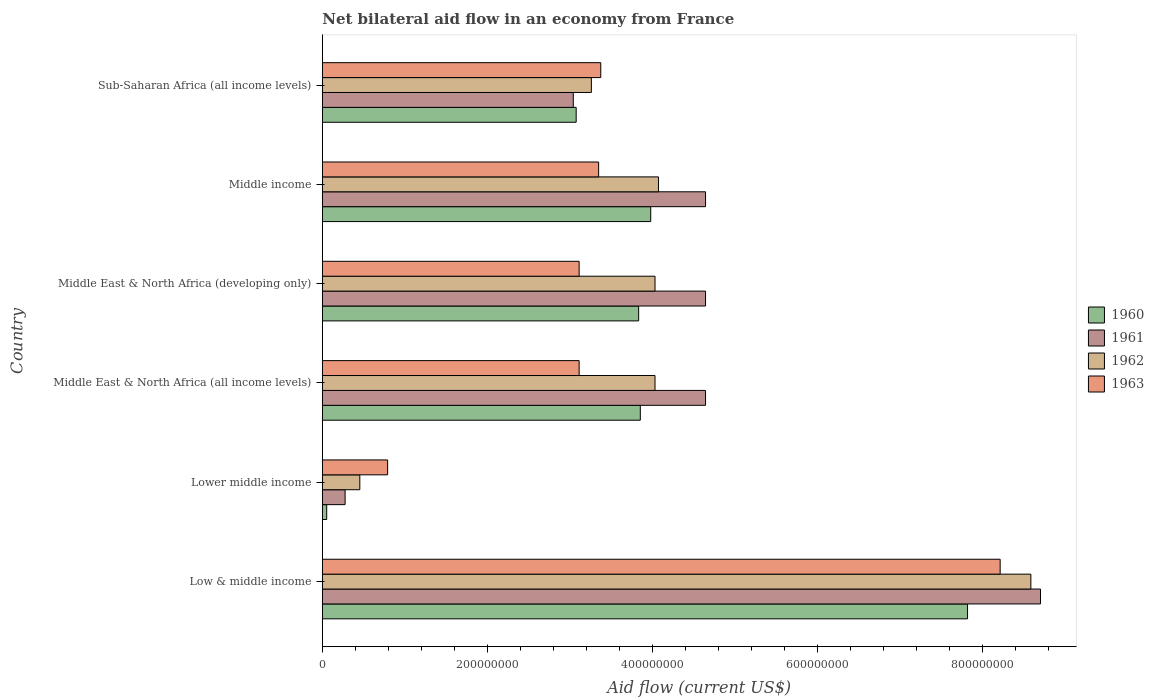How many different coloured bars are there?
Make the answer very short. 4. How many groups of bars are there?
Offer a very short reply. 6. How many bars are there on the 6th tick from the bottom?
Provide a short and direct response. 4. What is the label of the 2nd group of bars from the top?
Ensure brevity in your answer.  Middle income. What is the net bilateral aid flow in 1961 in Middle East & North Africa (all income levels)?
Give a very brief answer. 4.64e+08. Across all countries, what is the maximum net bilateral aid flow in 1960?
Your answer should be very brief. 7.82e+08. Across all countries, what is the minimum net bilateral aid flow in 1963?
Your answer should be compact. 7.91e+07. In which country was the net bilateral aid flow in 1960 maximum?
Give a very brief answer. Low & middle income. In which country was the net bilateral aid flow in 1963 minimum?
Keep it short and to the point. Lower middle income. What is the total net bilateral aid flow in 1962 in the graph?
Provide a short and direct response. 2.44e+09. What is the difference between the net bilateral aid flow in 1960 in Middle East & North Africa (developing only) and that in Sub-Saharan Africa (all income levels)?
Make the answer very short. 7.57e+07. What is the difference between the net bilateral aid flow in 1963 in Middle income and the net bilateral aid flow in 1960 in Middle East & North Africa (developing only)?
Ensure brevity in your answer.  -4.85e+07. What is the average net bilateral aid flow in 1962 per country?
Offer a terse response. 4.07e+08. What is the difference between the net bilateral aid flow in 1963 and net bilateral aid flow in 1962 in Sub-Saharan Africa (all income levels)?
Offer a very short reply. 1.14e+07. In how many countries, is the net bilateral aid flow in 1961 greater than 400000000 US$?
Ensure brevity in your answer.  4. What is the ratio of the net bilateral aid flow in 1963 in Lower middle income to that in Sub-Saharan Africa (all income levels)?
Make the answer very short. 0.23. Is the net bilateral aid flow in 1962 in Lower middle income less than that in Middle income?
Offer a terse response. Yes. Is the difference between the net bilateral aid flow in 1963 in Middle East & North Africa (developing only) and Middle income greater than the difference between the net bilateral aid flow in 1962 in Middle East & North Africa (developing only) and Middle income?
Keep it short and to the point. No. What is the difference between the highest and the second highest net bilateral aid flow in 1961?
Provide a succinct answer. 4.06e+08. What is the difference between the highest and the lowest net bilateral aid flow in 1961?
Your answer should be compact. 8.42e+08. What does the 1st bar from the top in Lower middle income represents?
Your answer should be very brief. 1963. Are all the bars in the graph horizontal?
Ensure brevity in your answer.  Yes. How many countries are there in the graph?
Ensure brevity in your answer.  6. What is the difference between two consecutive major ticks on the X-axis?
Offer a very short reply. 2.00e+08. Does the graph contain any zero values?
Offer a very short reply. No. Does the graph contain grids?
Offer a terse response. No. How many legend labels are there?
Your response must be concise. 4. How are the legend labels stacked?
Provide a short and direct response. Vertical. What is the title of the graph?
Keep it short and to the point. Net bilateral aid flow in an economy from France. Does "2006" appear as one of the legend labels in the graph?
Give a very brief answer. No. What is the Aid flow (current US$) in 1960 in Low & middle income?
Your answer should be compact. 7.82e+08. What is the Aid flow (current US$) in 1961 in Low & middle income?
Offer a very short reply. 8.70e+08. What is the Aid flow (current US$) of 1962 in Low & middle income?
Provide a short and direct response. 8.58e+08. What is the Aid flow (current US$) of 1963 in Low & middle income?
Ensure brevity in your answer.  8.21e+08. What is the Aid flow (current US$) of 1960 in Lower middle income?
Provide a succinct answer. 5.30e+06. What is the Aid flow (current US$) of 1961 in Lower middle income?
Your answer should be very brief. 2.76e+07. What is the Aid flow (current US$) of 1962 in Lower middle income?
Give a very brief answer. 4.54e+07. What is the Aid flow (current US$) of 1963 in Lower middle income?
Offer a terse response. 7.91e+07. What is the Aid flow (current US$) in 1960 in Middle East & North Africa (all income levels)?
Make the answer very short. 3.85e+08. What is the Aid flow (current US$) of 1961 in Middle East & North Africa (all income levels)?
Your answer should be compact. 4.64e+08. What is the Aid flow (current US$) of 1962 in Middle East & North Africa (all income levels)?
Your answer should be very brief. 4.03e+08. What is the Aid flow (current US$) of 1963 in Middle East & North Africa (all income levels)?
Your answer should be very brief. 3.11e+08. What is the Aid flow (current US$) in 1960 in Middle East & North Africa (developing only)?
Your response must be concise. 3.83e+08. What is the Aid flow (current US$) in 1961 in Middle East & North Africa (developing only)?
Offer a very short reply. 4.64e+08. What is the Aid flow (current US$) of 1962 in Middle East & North Africa (developing only)?
Keep it short and to the point. 4.03e+08. What is the Aid flow (current US$) in 1963 in Middle East & North Africa (developing only)?
Give a very brief answer. 3.11e+08. What is the Aid flow (current US$) of 1960 in Middle income?
Your response must be concise. 3.98e+08. What is the Aid flow (current US$) of 1961 in Middle income?
Keep it short and to the point. 4.64e+08. What is the Aid flow (current US$) in 1962 in Middle income?
Make the answer very short. 4.07e+08. What is the Aid flow (current US$) of 1963 in Middle income?
Your answer should be very brief. 3.35e+08. What is the Aid flow (current US$) of 1960 in Sub-Saharan Africa (all income levels)?
Make the answer very short. 3.08e+08. What is the Aid flow (current US$) in 1961 in Sub-Saharan Africa (all income levels)?
Provide a short and direct response. 3.04e+08. What is the Aid flow (current US$) in 1962 in Sub-Saharan Africa (all income levels)?
Provide a succinct answer. 3.26e+08. What is the Aid flow (current US$) in 1963 in Sub-Saharan Africa (all income levels)?
Keep it short and to the point. 3.37e+08. Across all countries, what is the maximum Aid flow (current US$) of 1960?
Your response must be concise. 7.82e+08. Across all countries, what is the maximum Aid flow (current US$) of 1961?
Ensure brevity in your answer.  8.70e+08. Across all countries, what is the maximum Aid flow (current US$) of 1962?
Your answer should be very brief. 8.58e+08. Across all countries, what is the maximum Aid flow (current US$) in 1963?
Offer a terse response. 8.21e+08. Across all countries, what is the minimum Aid flow (current US$) in 1960?
Your answer should be very brief. 5.30e+06. Across all countries, what is the minimum Aid flow (current US$) of 1961?
Provide a short and direct response. 2.76e+07. Across all countries, what is the minimum Aid flow (current US$) of 1962?
Your answer should be very brief. 4.54e+07. Across all countries, what is the minimum Aid flow (current US$) in 1963?
Provide a short and direct response. 7.91e+07. What is the total Aid flow (current US$) of 1960 in the graph?
Offer a very short reply. 2.26e+09. What is the total Aid flow (current US$) in 1961 in the graph?
Provide a succinct answer. 2.59e+09. What is the total Aid flow (current US$) of 1962 in the graph?
Provide a succinct answer. 2.44e+09. What is the total Aid flow (current US$) of 1963 in the graph?
Keep it short and to the point. 2.19e+09. What is the difference between the Aid flow (current US$) of 1960 in Low & middle income and that in Lower middle income?
Your response must be concise. 7.76e+08. What is the difference between the Aid flow (current US$) of 1961 in Low & middle income and that in Lower middle income?
Provide a short and direct response. 8.42e+08. What is the difference between the Aid flow (current US$) in 1962 in Low & middle income and that in Lower middle income?
Your answer should be very brief. 8.13e+08. What is the difference between the Aid flow (current US$) of 1963 in Low & middle income and that in Lower middle income?
Keep it short and to the point. 7.42e+08. What is the difference between the Aid flow (current US$) in 1960 in Low & middle income and that in Middle East & North Africa (all income levels)?
Your response must be concise. 3.96e+08. What is the difference between the Aid flow (current US$) of 1961 in Low & middle income and that in Middle East & North Africa (all income levels)?
Your response must be concise. 4.06e+08. What is the difference between the Aid flow (current US$) in 1962 in Low & middle income and that in Middle East & North Africa (all income levels)?
Offer a terse response. 4.55e+08. What is the difference between the Aid flow (current US$) of 1963 in Low & middle income and that in Middle East & North Africa (all income levels)?
Provide a short and direct response. 5.10e+08. What is the difference between the Aid flow (current US$) in 1960 in Low & middle income and that in Middle East & North Africa (developing only)?
Offer a terse response. 3.98e+08. What is the difference between the Aid flow (current US$) of 1961 in Low & middle income and that in Middle East & North Africa (developing only)?
Offer a very short reply. 4.06e+08. What is the difference between the Aid flow (current US$) of 1962 in Low & middle income and that in Middle East & North Africa (developing only)?
Your answer should be very brief. 4.55e+08. What is the difference between the Aid flow (current US$) of 1963 in Low & middle income and that in Middle East & North Africa (developing only)?
Make the answer very short. 5.10e+08. What is the difference between the Aid flow (current US$) of 1960 in Low & middle income and that in Middle income?
Provide a succinct answer. 3.84e+08. What is the difference between the Aid flow (current US$) of 1961 in Low & middle income and that in Middle income?
Your answer should be compact. 4.06e+08. What is the difference between the Aid flow (current US$) in 1962 in Low & middle income and that in Middle income?
Give a very brief answer. 4.51e+08. What is the difference between the Aid flow (current US$) of 1963 in Low & middle income and that in Middle income?
Offer a terse response. 4.86e+08. What is the difference between the Aid flow (current US$) of 1960 in Low & middle income and that in Sub-Saharan Africa (all income levels)?
Provide a succinct answer. 4.74e+08. What is the difference between the Aid flow (current US$) of 1961 in Low & middle income and that in Sub-Saharan Africa (all income levels)?
Your answer should be very brief. 5.66e+08. What is the difference between the Aid flow (current US$) in 1962 in Low & middle income and that in Sub-Saharan Africa (all income levels)?
Make the answer very short. 5.32e+08. What is the difference between the Aid flow (current US$) of 1963 in Low & middle income and that in Sub-Saharan Africa (all income levels)?
Your response must be concise. 4.84e+08. What is the difference between the Aid flow (current US$) of 1960 in Lower middle income and that in Middle East & North Africa (all income levels)?
Provide a short and direct response. -3.80e+08. What is the difference between the Aid flow (current US$) in 1961 in Lower middle income and that in Middle East & North Africa (all income levels)?
Make the answer very short. -4.37e+08. What is the difference between the Aid flow (current US$) in 1962 in Lower middle income and that in Middle East & North Africa (all income levels)?
Keep it short and to the point. -3.58e+08. What is the difference between the Aid flow (current US$) in 1963 in Lower middle income and that in Middle East & North Africa (all income levels)?
Your answer should be compact. -2.32e+08. What is the difference between the Aid flow (current US$) in 1960 in Lower middle income and that in Middle East & North Africa (developing only)?
Provide a short and direct response. -3.78e+08. What is the difference between the Aid flow (current US$) of 1961 in Lower middle income and that in Middle East & North Africa (developing only)?
Make the answer very short. -4.37e+08. What is the difference between the Aid flow (current US$) in 1962 in Lower middle income and that in Middle East & North Africa (developing only)?
Your answer should be compact. -3.58e+08. What is the difference between the Aid flow (current US$) of 1963 in Lower middle income and that in Middle East & North Africa (developing only)?
Offer a very short reply. -2.32e+08. What is the difference between the Aid flow (current US$) in 1960 in Lower middle income and that in Middle income?
Give a very brief answer. -3.92e+08. What is the difference between the Aid flow (current US$) in 1961 in Lower middle income and that in Middle income?
Ensure brevity in your answer.  -4.37e+08. What is the difference between the Aid flow (current US$) of 1962 in Lower middle income and that in Middle income?
Offer a very short reply. -3.62e+08. What is the difference between the Aid flow (current US$) in 1963 in Lower middle income and that in Middle income?
Make the answer very short. -2.56e+08. What is the difference between the Aid flow (current US$) of 1960 in Lower middle income and that in Sub-Saharan Africa (all income levels)?
Offer a terse response. -3.02e+08. What is the difference between the Aid flow (current US$) in 1961 in Lower middle income and that in Sub-Saharan Africa (all income levels)?
Make the answer very short. -2.76e+08. What is the difference between the Aid flow (current US$) of 1962 in Lower middle income and that in Sub-Saharan Africa (all income levels)?
Provide a succinct answer. -2.80e+08. What is the difference between the Aid flow (current US$) in 1963 in Lower middle income and that in Sub-Saharan Africa (all income levels)?
Give a very brief answer. -2.58e+08. What is the difference between the Aid flow (current US$) in 1961 in Middle East & North Africa (all income levels) and that in Middle East & North Africa (developing only)?
Your response must be concise. 0. What is the difference between the Aid flow (current US$) of 1960 in Middle East & North Africa (all income levels) and that in Middle income?
Ensure brevity in your answer.  -1.26e+07. What is the difference between the Aid flow (current US$) in 1961 in Middle East & North Africa (all income levels) and that in Middle income?
Offer a very short reply. 0. What is the difference between the Aid flow (current US$) in 1962 in Middle East & North Africa (all income levels) and that in Middle income?
Your response must be concise. -4.20e+06. What is the difference between the Aid flow (current US$) in 1963 in Middle East & North Africa (all income levels) and that in Middle income?
Give a very brief answer. -2.36e+07. What is the difference between the Aid flow (current US$) of 1960 in Middle East & North Africa (all income levels) and that in Sub-Saharan Africa (all income levels)?
Offer a very short reply. 7.77e+07. What is the difference between the Aid flow (current US$) of 1961 in Middle East & North Africa (all income levels) and that in Sub-Saharan Africa (all income levels)?
Offer a terse response. 1.60e+08. What is the difference between the Aid flow (current US$) in 1962 in Middle East & North Africa (all income levels) and that in Sub-Saharan Africa (all income levels)?
Your answer should be compact. 7.71e+07. What is the difference between the Aid flow (current US$) of 1963 in Middle East & North Africa (all income levels) and that in Sub-Saharan Africa (all income levels)?
Keep it short and to the point. -2.62e+07. What is the difference between the Aid flow (current US$) in 1960 in Middle East & North Africa (developing only) and that in Middle income?
Your answer should be compact. -1.46e+07. What is the difference between the Aid flow (current US$) of 1961 in Middle East & North Africa (developing only) and that in Middle income?
Your response must be concise. 0. What is the difference between the Aid flow (current US$) of 1962 in Middle East & North Africa (developing only) and that in Middle income?
Offer a terse response. -4.20e+06. What is the difference between the Aid flow (current US$) of 1963 in Middle East & North Africa (developing only) and that in Middle income?
Offer a very short reply. -2.36e+07. What is the difference between the Aid flow (current US$) of 1960 in Middle East & North Africa (developing only) and that in Sub-Saharan Africa (all income levels)?
Your answer should be compact. 7.57e+07. What is the difference between the Aid flow (current US$) in 1961 in Middle East & North Africa (developing only) and that in Sub-Saharan Africa (all income levels)?
Keep it short and to the point. 1.60e+08. What is the difference between the Aid flow (current US$) in 1962 in Middle East & North Africa (developing only) and that in Sub-Saharan Africa (all income levels)?
Give a very brief answer. 7.71e+07. What is the difference between the Aid flow (current US$) of 1963 in Middle East & North Africa (developing only) and that in Sub-Saharan Africa (all income levels)?
Offer a very short reply. -2.62e+07. What is the difference between the Aid flow (current US$) in 1960 in Middle income and that in Sub-Saharan Africa (all income levels)?
Your answer should be very brief. 9.03e+07. What is the difference between the Aid flow (current US$) in 1961 in Middle income and that in Sub-Saharan Africa (all income levels)?
Ensure brevity in your answer.  1.60e+08. What is the difference between the Aid flow (current US$) of 1962 in Middle income and that in Sub-Saharan Africa (all income levels)?
Offer a terse response. 8.13e+07. What is the difference between the Aid flow (current US$) in 1963 in Middle income and that in Sub-Saharan Africa (all income levels)?
Ensure brevity in your answer.  -2.60e+06. What is the difference between the Aid flow (current US$) of 1960 in Low & middle income and the Aid flow (current US$) of 1961 in Lower middle income?
Offer a very short reply. 7.54e+08. What is the difference between the Aid flow (current US$) in 1960 in Low & middle income and the Aid flow (current US$) in 1962 in Lower middle income?
Provide a succinct answer. 7.36e+08. What is the difference between the Aid flow (current US$) in 1960 in Low & middle income and the Aid flow (current US$) in 1963 in Lower middle income?
Ensure brevity in your answer.  7.02e+08. What is the difference between the Aid flow (current US$) in 1961 in Low & middle income and the Aid flow (current US$) in 1962 in Lower middle income?
Provide a succinct answer. 8.25e+08. What is the difference between the Aid flow (current US$) of 1961 in Low & middle income and the Aid flow (current US$) of 1963 in Lower middle income?
Your answer should be compact. 7.91e+08. What is the difference between the Aid flow (current US$) in 1962 in Low & middle income and the Aid flow (current US$) in 1963 in Lower middle income?
Ensure brevity in your answer.  7.79e+08. What is the difference between the Aid flow (current US$) in 1960 in Low & middle income and the Aid flow (current US$) in 1961 in Middle East & North Africa (all income levels)?
Your answer should be compact. 3.17e+08. What is the difference between the Aid flow (current US$) of 1960 in Low & middle income and the Aid flow (current US$) of 1962 in Middle East & North Africa (all income levels)?
Give a very brief answer. 3.79e+08. What is the difference between the Aid flow (current US$) of 1960 in Low & middle income and the Aid flow (current US$) of 1963 in Middle East & North Africa (all income levels)?
Your answer should be very brief. 4.70e+08. What is the difference between the Aid flow (current US$) in 1961 in Low & middle income and the Aid flow (current US$) in 1962 in Middle East & North Africa (all income levels)?
Keep it short and to the point. 4.67e+08. What is the difference between the Aid flow (current US$) of 1961 in Low & middle income and the Aid flow (current US$) of 1963 in Middle East & North Africa (all income levels)?
Keep it short and to the point. 5.59e+08. What is the difference between the Aid flow (current US$) of 1962 in Low & middle income and the Aid flow (current US$) of 1963 in Middle East & North Africa (all income levels)?
Provide a short and direct response. 5.47e+08. What is the difference between the Aid flow (current US$) in 1960 in Low & middle income and the Aid flow (current US$) in 1961 in Middle East & North Africa (developing only)?
Your answer should be very brief. 3.17e+08. What is the difference between the Aid flow (current US$) in 1960 in Low & middle income and the Aid flow (current US$) in 1962 in Middle East & North Africa (developing only)?
Offer a very short reply. 3.79e+08. What is the difference between the Aid flow (current US$) in 1960 in Low & middle income and the Aid flow (current US$) in 1963 in Middle East & North Africa (developing only)?
Ensure brevity in your answer.  4.70e+08. What is the difference between the Aid flow (current US$) in 1961 in Low & middle income and the Aid flow (current US$) in 1962 in Middle East & North Africa (developing only)?
Make the answer very short. 4.67e+08. What is the difference between the Aid flow (current US$) in 1961 in Low & middle income and the Aid flow (current US$) in 1963 in Middle East & North Africa (developing only)?
Ensure brevity in your answer.  5.59e+08. What is the difference between the Aid flow (current US$) in 1962 in Low & middle income and the Aid flow (current US$) in 1963 in Middle East & North Africa (developing only)?
Provide a short and direct response. 5.47e+08. What is the difference between the Aid flow (current US$) of 1960 in Low & middle income and the Aid flow (current US$) of 1961 in Middle income?
Provide a short and direct response. 3.17e+08. What is the difference between the Aid flow (current US$) of 1960 in Low & middle income and the Aid flow (current US$) of 1962 in Middle income?
Keep it short and to the point. 3.74e+08. What is the difference between the Aid flow (current US$) of 1960 in Low & middle income and the Aid flow (current US$) of 1963 in Middle income?
Make the answer very short. 4.47e+08. What is the difference between the Aid flow (current US$) of 1961 in Low & middle income and the Aid flow (current US$) of 1962 in Middle income?
Provide a succinct answer. 4.63e+08. What is the difference between the Aid flow (current US$) in 1961 in Low & middle income and the Aid flow (current US$) in 1963 in Middle income?
Provide a succinct answer. 5.35e+08. What is the difference between the Aid flow (current US$) of 1962 in Low & middle income and the Aid flow (current US$) of 1963 in Middle income?
Your answer should be compact. 5.24e+08. What is the difference between the Aid flow (current US$) of 1960 in Low & middle income and the Aid flow (current US$) of 1961 in Sub-Saharan Africa (all income levels)?
Keep it short and to the point. 4.78e+08. What is the difference between the Aid flow (current US$) of 1960 in Low & middle income and the Aid flow (current US$) of 1962 in Sub-Saharan Africa (all income levels)?
Your response must be concise. 4.56e+08. What is the difference between the Aid flow (current US$) in 1960 in Low & middle income and the Aid flow (current US$) in 1963 in Sub-Saharan Africa (all income levels)?
Offer a very short reply. 4.44e+08. What is the difference between the Aid flow (current US$) in 1961 in Low & middle income and the Aid flow (current US$) in 1962 in Sub-Saharan Africa (all income levels)?
Keep it short and to the point. 5.44e+08. What is the difference between the Aid flow (current US$) of 1961 in Low & middle income and the Aid flow (current US$) of 1963 in Sub-Saharan Africa (all income levels)?
Give a very brief answer. 5.33e+08. What is the difference between the Aid flow (current US$) of 1962 in Low & middle income and the Aid flow (current US$) of 1963 in Sub-Saharan Africa (all income levels)?
Your answer should be compact. 5.21e+08. What is the difference between the Aid flow (current US$) in 1960 in Lower middle income and the Aid flow (current US$) in 1961 in Middle East & North Africa (all income levels)?
Give a very brief answer. -4.59e+08. What is the difference between the Aid flow (current US$) in 1960 in Lower middle income and the Aid flow (current US$) in 1962 in Middle East & North Africa (all income levels)?
Keep it short and to the point. -3.98e+08. What is the difference between the Aid flow (current US$) in 1960 in Lower middle income and the Aid flow (current US$) in 1963 in Middle East & North Africa (all income levels)?
Your response must be concise. -3.06e+08. What is the difference between the Aid flow (current US$) of 1961 in Lower middle income and the Aid flow (current US$) of 1962 in Middle East & North Africa (all income levels)?
Offer a terse response. -3.75e+08. What is the difference between the Aid flow (current US$) in 1961 in Lower middle income and the Aid flow (current US$) in 1963 in Middle East & North Africa (all income levels)?
Your answer should be very brief. -2.84e+08. What is the difference between the Aid flow (current US$) in 1962 in Lower middle income and the Aid flow (current US$) in 1963 in Middle East & North Africa (all income levels)?
Make the answer very short. -2.66e+08. What is the difference between the Aid flow (current US$) in 1960 in Lower middle income and the Aid flow (current US$) in 1961 in Middle East & North Africa (developing only)?
Provide a short and direct response. -4.59e+08. What is the difference between the Aid flow (current US$) of 1960 in Lower middle income and the Aid flow (current US$) of 1962 in Middle East & North Africa (developing only)?
Offer a terse response. -3.98e+08. What is the difference between the Aid flow (current US$) in 1960 in Lower middle income and the Aid flow (current US$) in 1963 in Middle East & North Africa (developing only)?
Your answer should be compact. -3.06e+08. What is the difference between the Aid flow (current US$) in 1961 in Lower middle income and the Aid flow (current US$) in 1962 in Middle East & North Africa (developing only)?
Keep it short and to the point. -3.75e+08. What is the difference between the Aid flow (current US$) in 1961 in Lower middle income and the Aid flow (current US$) in 1963 in Middle East & North Africa (developing only)?
Provide a succinct answer. -2.84e+08. What is the difference between the Aid flow (current US$) of 1962 in Lower middle income and the Aid flow (current US$) of 1963 in Middle East & North Africa (developing only)?
Your answer should be very brief. -2.66e+08. What is the difference between the Aid flow (current US$) in 1960 in Lower middle income and the Aid flow (current US$) in 1961 in Middle income?
Your answer should be very brief. -4.59e+08. What is the difference between the Aid flow (current US$) in 1960 in Lower middle income and the Aid flow (current US$) in 1962 in Middle income?
Offer a very short reply. -4.02e+08. What is the difference between the Aid flow (current US$) in 1960 in Lower middle income and the Aid flow (current US$) in 1963 in Middle income?
Provide a succinct answer. -3.29e+08. What is the difference between the Aid flow (current US$) of 1961 in Lower middle income and the Aid flow (current US$) of 1962 in Middle income?
Offer a very short reply. -3.80e+08. What is the difference between the Aid flow (current US$) in 1961 in Lower middle income and the Aid flow (current US$) in 1963 in Middle income?
Your response must be concise. -3.07e+08. What is the difference between the Aid flow (current US$) of 1962 in Lower middle income and the Aid flow (current US$) of 1963 in Middle income?
Provide a short and direct response. -2.89e+08. What is the difference between the Aid flow (current US$) of 1960 in Lower middle income and the Aid flow (current US$) of 1961 in Sub-Saharan Africa (all income levels)?
Provide a short and direct response. -2.99e+08. What is the difference between the Aid flow (current US$) of 1960 in Lower middle income and the Aid flow (current US$) of 1962 in Sub-Saharan Africa (all income levels)?
Provide a succinct answer. -3.21e+08. What is the difference between the Aid flow (current US$) in 1960 in Lower middle income and the Aid flow (current US$) in 1963 in Sub-Saharan Africa (all income levels)?
Keep it short and to the point. -3.32e+08. What is the difference between the Aid flow (current US$) in 1961 in Lower middle income and the Aid flow (current US$) in 1962 in Sub-Saharan Africa (all income levels)?
Provide a short and direct response. -2.98e+08. What is the difference between the Aid flow (current US$) in 1961 in Lower middle income and the Aid flow (current US$) in 1963 in Sub-Saharan Africa (all income levels)?
Provide a short and direct response. -3.10e+08. What is the difference between the Aid flow (current US$) of 1962 in Lower middle income and the Aid flow (current US$) of 1963 in Sub-Saharan Africa (all income levels)?
Keep it short and to the point. -2.92e+08. What is the difference between the Aid flow (current US$) in 1960 in Middle East & North Africa (all income levels) and the Aid flow (current US$) in 1961 in Middle East & North Africa (developing only)?
Provide a succinct answer. -7.90e+07. What is the difference between the Aid flow (current US$) of 1960 in Middle East & North Africa (all income levels) and the Aid flow (current US$) of 1962 in Middle East & North Africa (developing only)?
Your answer should be compact. -1.78e+07. What is the difference between the Aid flow (current US$) in 1960 in Middle East & North Africa (all income levels) and the Aid flow (current US$) in 1963 in Middle East & North Africa (developing only)?
Provide a short and direct response. 7.41e+07. What is the difference between the Aid flow (current US$) in 1961 in Middle East & North Africa (all income levels) and the Aid flow (current US$) in 1962 in Middle East & North Africa (developing only)?
Your answer should be very brief. 6.12e+07. What is the difference between the Aid flow (current US$) in 1961 in Middle East & North Africa (all income levels) and the Aid flow (current US$) in 1963 in Middle East & North Africa (developing only)?
Provide a short and direct response. 1.53e+08. What is the difference between the Aid flow (current US$) of 1962 in Middle East & North Africa (all income levels) and the Aid flow (current US$) of 1963 in Middle East & North Africa (developing only)?
Give a very brief answer. 9.19e+07. What is the difference between the Aid flow (current US$) in 1960 in Middle East & North Africa (all income levels) and the Aid flow (current US$) in 1961 in Middle income?
Provide a short and direct response. -7.90e+07. What is the difference between the Aid flow (current US$) of 1960 in Middle East & North Africa (all income levels) and the Aid flow (current US$) of 1962 in Middle income?
Make the answer very short. -2.20e+07. What is the difference between the Aid flow (current US$) of 1960 in Middle East & North Africa (all income levels) and the Aid flow (current US$) of 1963 in Middle income?
Your response must be concise. 5.05e+07. What is the difference between the Aid flow (current US$) of 1961 in Middle East & North Africa (all income levels) and the Aid flow (current US$) of 1962 in Middle income?
Provide a succinct answer. 5.70e+07. What is the difference between the Aid flow (current US$) in 1961 in Middle East & North Africa (all income levels) and the Aid flow (current US$) in 1963 in Middle income?
Your answer should be compact. 1.30e+08. What is the difference between the Aid flow (current US$) in 1962 in Middle East & North Africa (all income levels) and the Aid flow (current US$) in 1963 in Middle income?
Your answer should be very brief. 6.83e+07. What is the difference between the Aid flow (current US$) in 1960 in Middle East & North Africa (all income levels) and the Aid flow (current US$) in 1961 in Sub-Saharan Africa (all income levels)?
Offer a terse response. 8.12e+07. What is the difference between the Aid flow (current US$) in 1960 in Middle East & North Africa (all income levels) and the Aid flow (current US$) in 1962 in Sub-Saharan Africa (all income levels)?
Ensure brevity in your answer.  5.93e+07. What is the difference between the Aid flow (current US$) of 1960 in Middle East & North Africa (all income levels) and the Aid flow (current US$) of 1963 in Sub-Saharan Africa (all income levels)?
Give a very brief answer. 4.79e+07. What is the difference between the Aid flow (current US$) of 1961 in Middle East & North Africa (all income levels) and the Aid flow (current US$) of 1962 in Sub-Saharan Africa (all income levels)?
Make the answer very short. 1.38e+08. What is the difference between the Aid flow (current US$) in 1961 in Middle East & North Africa (all income levels) and the Aid flow (current US$) in 1963 in Sub-Saharan Africa (all income levels)?
Provide a succinct answer. 1.27e+08. What is the difference between the Aid flow (current US$) in 1962 in Middle East & North Africa (all income levels) and the Aid flow (current US$) in 1963 in Sub-Saharan Africa (all income levels)?
Give a very brief answer. 6.57e+07. What is the difference between the Aid flow (current US$) in 1960 in Middle East & North Africa (developing only) and the Aid flow (current US$) in 1961 in Middle income?
Make the answer very short. -8.10e+07. What is the difference between the Aid flow (current US$) in 1960 in Middle East & North Africa (developing only) and the Aid flow (current US$) in 1962 in Middle income?
Your answer should be very brief. -2.40e+07. What is the difference between the Aid flow (current US$) in 1960 in Middle East & North Africa (developing only) and the Aid flow (current US$) in 1963 in Middle income?
Provide a short and direct response. 4.85e+07. What is the difference between the Aid flow (current US$) in 1961 in Middle East & North Africa (developing only) and the Aid flow (current US$) in 1962 in Middle income?
Ensure brevity in your answer.  5.70e+07. What is the difference between the Aid flow (current US$) of 1961 in Middle East & North Africa (developing only) and the Aid flow (current US$) of 1963 in Middle income?
Offer a terse response. 1.30e+08. What is the difference between the Aid flow (current US$) in 1962 in Middle East & North Africa (developing only) and the Aid flow (current US$) in 1963 in Middle income?
Your answer should be very brief. 6.83e+07. What is the difference between the Aid flow (current US$) of 1960 in Middle East & North Africa (developing only) and the Aid flow (current US$) of 1961 in Sub-Saharan Africa (all income levels)?
Provide a succinct answer. 7.92e+07. What is the difference between the Aid flow (current US$) in 1960 in Middle East & North Africa (developing only) and the Aid flow (current US$) in 1962 in Sub-Saharan Africa (all income levels)?
Your response must be concise. 5.73e+07. What is the difference between the Aid flow (current US$) in 1960 in Middle East & North Africa (developing only) and the Aid flow (current US$) in 1963 in Sub-Saharan Africa (all income levels)?
Provide a succinct answer. 4.59e+07. What is the difference between the Aid flow (current US$) in 1961 in Middle East & North Africa (developing only) and the Aid flow (current US$) in 1962 in Sub-Saharan Africa (all income levels)?
Give a very brief answer. 1.38e+08. What is the difference between the Aid flow (current US$) of 1961 in Middle East & North Africa (developing only) and the Aid flow (current US$) of 1963 in Sub-Saharan Africa (all income levels)?
Your answer should be compact. 1.27e+08. What is the difference between the Aid flow (current US$) in 1962 in Middle East & North Africa (developing only) and the Aid flow (current US$) in 1963 in Sub-Saharan Africa (all income levels)?
Your answer should be very brief. 6.57e+07. What is the difference between the Aid flow (current US$) in 1960 in Middle income and the Aid flow (current US$) in 1961 in Sub-Saharan Africa (all income levels)?
Provide a short and direct response. 9.38e+07. What is the difference between the Aid flow (current US$) in 1960 in Middle income and the Aid flow (current US$) in 1962 in Sub-Saharan Africa (all income levels)?
Provide a succinct answer. 7.19e+07. What is the difference between the Aid flow (current US$) in 1960 in Middle income and the Aid flow (current US$) in 1963 in Sub-Saharan Africa (all income levels)?
Keep it short and to the point. 6.05e+07. What is the difference between the Aid flow (current US$) of 1961 in Middle income and the Aid flow (current US$) of 1962 in Sub-Saharan Africa (all income levels)?
Provide a short and direct response. 1.38e+08. What is the difference between the Aid flow (current US$) of 1961 in Middle income and the Aid flow (current US$) of 1963 in Sub-Saharan Africa (all income levels)?
Offer a terse response. 1.27e+08. What is the difference between the Aid flow (current US$) in 1962 in Middle income and the Aid flow (current US$) in 1963 in Sub-Saharan Africa (all income levels)?
Offer a terse response. 6.99e+07. What is the average Aid flow (current US$) in 1960 per country?
Provide a short and direct response. 3.77e+08. What is the average Aid flow (current US$) of 1961 per country?
Keep it short and to the point. 4.32e+08. What is the average Aid flow (current US$) of 1962 per country?
Offer a very short reply. 4.07e+08. What is the average Aid flow (current US$) in 1963 per country?
Offer a very short reply. 3.66e+08. What is the difference between the Aid flow (current US$) of 1960 and Aid flow (current US$) of 1961 in Low & middle income?
Provide a short and direct response. -8.84e+07. What is the difference between the Aid flow (current US$) of 1960 and Aid flow (current US$) of 1962 in Low & middle income?
Provide a succinct answer. -7.67e+07. What is the difference between the Aid flow (current US$) of 1960 and Aid flow (current US$) of 1963 in Low & middle income?
Your answer should be very brief. -3.95e+07. What is the difference between the Aid flow (current US$) in 1961 and Aid flow (current US$) in 1962 in Low & middle income?
Offer a terse response. 1.17e+07. What is the difference between the Aid flow (current US$) of 1961 and Aid flow (current US$) of 1963 in Low & middle income?
Your answer should be compact. 4.89e+07. What is the difference between the Aid flow (current US$) of 1962 and Aid flow (current US$) of 1963 in Low & middle income?
Offer a very short reply. 3.72e+07. What is the difference between the Aid flow (current US$) in 1960 and Aid flow (current US$) in 1961 in Lower middle income?
Offer a very short reply. -2.23e+07. What is the difference between the Aid flow (current US$) of 1960 and Aid flow (current US$) of 1962 in Lower middle income?
Your response must be concise. -4.01e+07. What is the difference between the Aid flow (current US$) in 1960 and Aid flow (current US$) in 1963 in Lower middle income?
Provide a short and direct response. -7.38e+07. What is the difference between the Aid flow (current US$) of 1961 and Aid flow (current US$) of 1962 in Lower middle income?
Your response must be concise. -1.78e+07. What is the difference between the Aid flow (current US$) in 1961 and Aid flow (current US$) in 1963 in Lower middle income?
Provide a short and direct response. -5.15e+07. What is the difference between the Aid flow (current US$) in 1962 and Aid flow (current US$) in 1963 in Lower middle income?
Your response must be concise. -3.37e+07. What is the difference between the Aid flow (current US$) in 1960 and Aid flow (current US$) in 1961 in Middle East & North Africa (all income levels)?
Provide a succinct answer. -7.90e+07. What is the difference between the Aid flow (current US$) in 1960 and Aid flow (current US$) in 1962 in Middle East & North Africa (all income levels)?
Your answer should be compact. -1.78e+07. What is the difference between the Aid flow (current US$) of 1960 and Aid flow (current US$) of 1963 in Middle East & North Africa (all income levels)?
Your answer should be compact. 7.41e+07. What is the difference between the Aid flow (current US$) of 1961 and Aid flow (current US$) of 1962 in Middle East & North Africa (all income levels)?
Ensure brevity in your answer.  6.12e+07. What is the difference between the Aid flow (current US$) of 1961 and Aid flow (current US$) of 1963 in Middle East & North Africa (all income levels)?
Provide a succinct answer. 1.53e+08. What is the difference between the Aid flow (current US$) in 1962 and Aid flow (current US$) in 1963 in Middle East & North Africa (all income levels)?
Make the answer very short. 9.19e+07. What is the difference between the Aid flow (current US$) of 1960 and Aid flow (current US$) of 1961 in Middle East & North Africa (developing only)?
Offer a terse response. -8.10e+07. What is the difference between the Aid flow (current US$) of 1960 and Aid flow (current US$) of 1962 in Middle East & North Africa (developing only)?
Give a very brief answer. -1.98e+07. What is the difference between the Aid flow (current US$) of 1960 and Aid flow (current US$) of 1963 in Middle East & North Africa (developing only)?
Offer a terse response. 7.21e+07. What is the difference between the Aid flow (current US$) of 1961 and Aid flow (current US$) of 1962 in Middle East & North Africa (developing only)?
Offer a very short reply. 6.12e+07. What is the difference between the Aid flow (current US$) of 1961 and Aid flow (current US$) of 1963 in Middle East & North Africa (developing only)?
Offer a terse response. 1.53e+08. What is the difference between the Aid flow (current US$) in 1962 and Aid flow (current US$) in 1963 in Middle East & North Africa (developing only)?
Your answer should be compact. 9.19e+07. What is the difference between the Aid flow (current US$) of 1960 and Aid flow (current US$) of 1961 in Middle income?
Offer a terse response. -6.64e+07. What is the difference between the Aid flow (current US$) of 1960 and Aid flow (current US$) of 1962 in Middle income?
Offer a very short reply. -9.40e+06. What is the difference between the Aid flow (current US$) of 1960 and Aid flow (current US$) of 1963 in Middle income?
Offer a terse response. 6.31e+07. What is the difference between the Aid flow (current US$) of 1961 and Aid flow (current US$) of 1962 in Middle income?
Provide a short and direct response. 5.70e+07. What is the difference between the Aid flow (current US$) of 1961 and Aid flow (current US$) of 1963 in Middle income?
Ensure brevity in your answer.  1.30e+08. What is the difference between the Aid flow (current US$) in 1962 and Aid flow (current US$) in 1963 in Middle income?
Make the answer very short. 7.25e+07. What is the difference between the Aid flow (current US$) in 1960 and Aid flow (current US$) in 1961 in Sub-Saharan Africa (all income levels)?
Keep it short and to the point. 3.50e+06. What is the difference between the Aid flow (current US$) in 1960 and Aid flow (current US$) in 1962 in Sub-Saharan Africa (all income levels)?
Give a very brief answer. -1.84e+07. What is the difference between the Aid flow (current US$) of 1960 and Aid flow (current US$) of 1963 in Sub-Saharan Africa (all income levels)?
Your answer should be very brief. -2.98e+07. What is the difference between the Aid flow (current US$) of 1961 and Aid flow (current US$) of 1962 in Sub-Saharan Africa (all income levels)?
Offer a terse response. -2.19e+07. What is the difference between the Aid flow (current US$) in 1961 and Aid flow (current US$) in 1963 in Sub-Saharan Africa (all income levels)?
Your answer should be very brief. -3.33e+07. What is the difference between the Aid flow (current US$) in 1962 and Aid flow (current US$) in 1963 in Sub-Saharan Africa (all income levels)?
Provide a succinct answer. -1.14e+07. What is the ratio of the Aid flow (current US$) in 1960 in Low & middle income to that in Lower middle income?
Provide a succinct answer. 147.47. What is the ratio of the Aid flow (current US$) in 1961 in Low & middle income to that in Lower middle income?
Make the answer very short. 31.52. What is the ratio of the Aid flow (current US$) in 1962 in Low & middle income to that in Lower middle income?
Ensure brevity in your answer.  18.91. What is the ratio of the Aid flow (current US$) in 1963 in Low & middle income to that in Lower middle income?
Your answer should be compact. 10.38. What is the ratio of the Aid flow (current US$) of 1960 in Low & middle income to that in Middle East & North Africa (all income levels)?
Offer a terse response. 2.03. What is the ratio of the Aid flow (current US$) of 1961 in Low & middle income to that in Middle East & North Africa (all income levels)?
Your response must be concise. 1.87. What is the ratio of the Aid flow (current US$) in 1962 in Low & middle income to that in Middle East & North Africa (all income levels)?
Ensure brevity in your answer.  2.13. What is the ratio of the Aid flow (current US$) of 1963 in Low & middle income to that in Middle East & North Africa (all income levels)?
Provide a succinct answer. 2.64. What is the ratio of the Aid flow (current US$) in 1960 in Low & middle income to that in Middle East & North Africa (developing only)?
Your response must be concise. 2.04. What is the ratio of the Aid flow (current US$) of 1961 in Low & middle income to that in Middle East & North Africa (developing only)?
Your answer should be very brief. 1.87. What is the ratio of the Aid flow (current US$) in 1962 in Low & middle income to that in Middle East & North Africa (developing only)?
Give a very brief answer. 2.13. What is the ratio of the Aid flow (current US$) of 1963 in Low & middle income to that in Middle East & North Africa (developing only)?
Provide a short and direct response. 2.64. What is the ratio of the Aid flow (current US$) of 1960 in Low & middle income to that in Middle income?
Your answer should be compact. 1.96. What is the ratio of the Aid flow (current US$) of 1961 in Low & middle income to that in Middle income?
Make the answer very short. 1.87. What is the ratio of the Aid flow (current US$) of 1962 in Low & middle income to that in Middle income?
Provide a succinct answer. 2.11. What is the ratio of the Aid flow (current US$) of 1963 in Low & middle income to that in Middle income?
Give a very brief answer. 2.45. What is the ratio of the Aid flow (current US$) of 1960 in Low & middle income to that in Sub-Saharan Africa (all income levels)?
Your answer should be compact. 2.54. What is the ratio of the Aid flow (current US$) of 1961 in Low & middle income to that in Sub-Saharan Africa (all income levels)?
Your response must be concise. 2.86. What is the ratio of the Aid flow (current US$) in 1962 in Low & middle income to that in Sub-Saharan Africa (all income levels)?
Offer a very short reply. 2.63. What is the ratio of the Aid flow (current US$) in 1963 in Low & middle income to that in Sub-Saharan Africa (all income levels)?
Provide a short and direct response. 2.43. What is the ratio of the Aid flow (current US$) in 1960 in Lower middle income to that in Middle East & North Africa (all income levels)?
Make the answer very short. 0.01. What is the ratio of the Aid flow (current US$) in 1961 in Lower middle income to that in Middle East & North Africa (all income levels)?
Make the answer very short. 0.06. What is the ratio of the Aid flow (current US$) in 1962 in Lower middle income to that in Middle East & North Africa (all income levels)?
Make the answer very short. 0.11. What is the ratio of the Aid flow (current US$) in 1963 in Lower middle income to that in Middle East & North Africa (all income levels)?
Provide a succinct answer. 0.25. What is the ratio of the Aid flow (current US$) in 1960 in Lower middle income to that in Middle East & North Africa (developing only)?
Keep it short and to the point. 0.01. What is the ratio of the Aid flow (current US$) in 1961 in Lower middle income to that in Middle East & North Africa (developing only)?
Provide a succinct answer. 0.06. What is the ratio of the Aid flow (current US$) of 1962 in Lower middle income to that in Middle East & North Africa (developing only)?
Your response must be concise. 0.11. What is the ratio of the Aid flow (current US$) in 1963 in Lower middle income to that in Middle East & North Africa (developing only)?
Give a very brief answer. 0.25. What is the ratio of the Aid flow (current US$) of 1960 in Lower middle income to that in Middle income?
Ensure brevity in your answer.  0.01. What is the ratio of the Aid flow (current US$) in 1961 in Lower middle income to that in Middle income?
Make the answer very short. 0.06. What is the ratio of the Aid flow (current US$) of 1962 in Lower middle income to that in Middle income?
Your answer should be compact. 0.11. What is the ratio of the Aid flow (current US$) in 1963 in Lower middle income to that in Middle income?
Make the answer very short. 0.24. What is the ratio of the Aid flow (current US$) of 1960 in Lower middle income to that in Sub-Saharan Africa (all income levels)?
Ensure brevity in your answer.  0.02. What is the ratio of the Aid flow (current US$) in 1961 in Lower middle income to that in Sub-Saharan Africa (all income levels)?
Ensure brevity in your answer.  0.09. What is the ratio of the Aid flow (current US$) of 1962 in Lower middle income to that in Sub-Saharan Africa (all income levels)?
Offer a terse response. 0.14. What is the ratio of the Aid flow (current US$) in 1963 in Lower middle income to that in Sub-Saharan Africa (all income levels)?
Your answer should be compact. 0.23. What is the ratio of the Aid flow (current US$) of 1960 in Middle East & North Africa (all income levels) to that in Middle East & North Africa (developing only)?
Provide a succinct answer. 1.01. What is the ratio of the Aid flow (current US$) of 1963 in Middle East & North Africa (all income levels) to that in Middle East & North Africa (developing only)?
Give a very brief answer. 1. What is the ratio of the Aid flow (current US$) in 1960 in Middle East & North Africa (all income levels) to that in Middle income?
Give a very brief answer. 0.97. What is the ratio of the Aid flow (current US$) in 1963 in Middle East & North Africa (all income levels) to that in Middle income?
Offer a very short reply. 0.93. What is the ratio of the Aid flow (current US$) of 1960 in Middle East & North Africa (all income levels) to that in Sub-Saharan Africa (all income levels)?
Offer a terse response. 1.25. What is the ratio of the Aid flow (current US$) in 1961 in Middle East & North Africa (all income levels) to that in Sub-Saharan Africa (all income levels)?
Your answer should be compact. 1.53. What is the ratio of the Aid flow (current US$) of 1962 in Middle East & North Africa (all income levels) to that in Sub-Saharan Africa (all income levels)?
Your answer should be very brief. 1.24. What is the ratio of the Aid flow (current US$) of 1963 in Middle East & North Africa (all income levels) to that in Sub-Saharan Africa (all income levels)?
Provide a short and direct response. 0.92. What is the ratio of the Aid flow (current US$) of 1960 in Middle East & North Africa (developing only) to that in Middle income?
Provide a short and direct response. 0.96. What is the ratio of the Aid flow (current US$) of 1962 in Middle East & North Africa (developing only) to that in Middle income?
Keep it short and to the point. 0.99. What is the ratio of the Aid flow (current US$) of 1963 in Middle East & North Africa (developing only) to that in Middle income?
Provide a succinct answer. 0.93. What is the ratio of the Aid flow (current US$) in 1960 in Middle East & North Africa (developing only) to that in Sub-Saharan Africa (all income levels)?
Provide a short and direct response. 1.25. What is the ratio of the Aid flow (current US$) in 1961 in Middle East & North Africa (developing only) to that in Sub-Saharan Africa (all income levels)?
Provide a short and direct response. 1.53. What is the ratio of the Aid flow (current US$) in 1962 in Middle East & North Africa (developing only) to that in Sub-Saharan Africa (all income levels)?
Make the answer very short. 1.24. What is the ratio of the Aid flow (current US$) in 1963 in Middle East & North Africa (developing only) to that in Sub-Saharan Africa (all income levels)?
Make the answer very short. 0.92. What is the ratio of the Aid flow (current US$) of 1960 in Middle income to that in Sub-Saharan Africa (all income levels)?
Provide a succinct answer. 1.29. What is the ratio of the Aid flow (current US$) of 1961 in Middle income to that in Sub-Saharan Africa (all income levels)?
Your answer should be compact. 1.53. What is the ratio of the Aid flow (current US$) of 1962 in Middle income to that in Sub-Saharan Africa (all income levels)?
Provide a short and direct response. 1.25. What is the difference between the highest and the second highest Aid flow (current US$) of 1960?
Your answer should be very brief. 3.84e+08. What is the difference between the highest and the second highest Aid flow (current US$) in 1961?
Give a very brief answer. 4.06e+08. What is the difference between the highest and the second highest Aid flow (current US$) of 1962?
Keep it short and to the point. 4.51e+08. What is the difference between the highest and the second highest Aid flow (current US$) of 1963?
Make the answer very short. 4.84e+08. What is the difference between the highest and the lowest Aid flow (current US$) in 1960?
Your answer should be very brief. 7.76e+08. What is the difference between the highest and the lowest Aid flow (current US$) in 1961?
Provide a succinct answer. 8.42e+08. What is the difference between the highest and the lowest Aid flow (current US$) of 1962?
Offer a very short reply. 8.13e+08. What is the difference between the highest and the lowest Aid flow (current US$) of 1963?
Make the answer very short. 7.42e+08. 